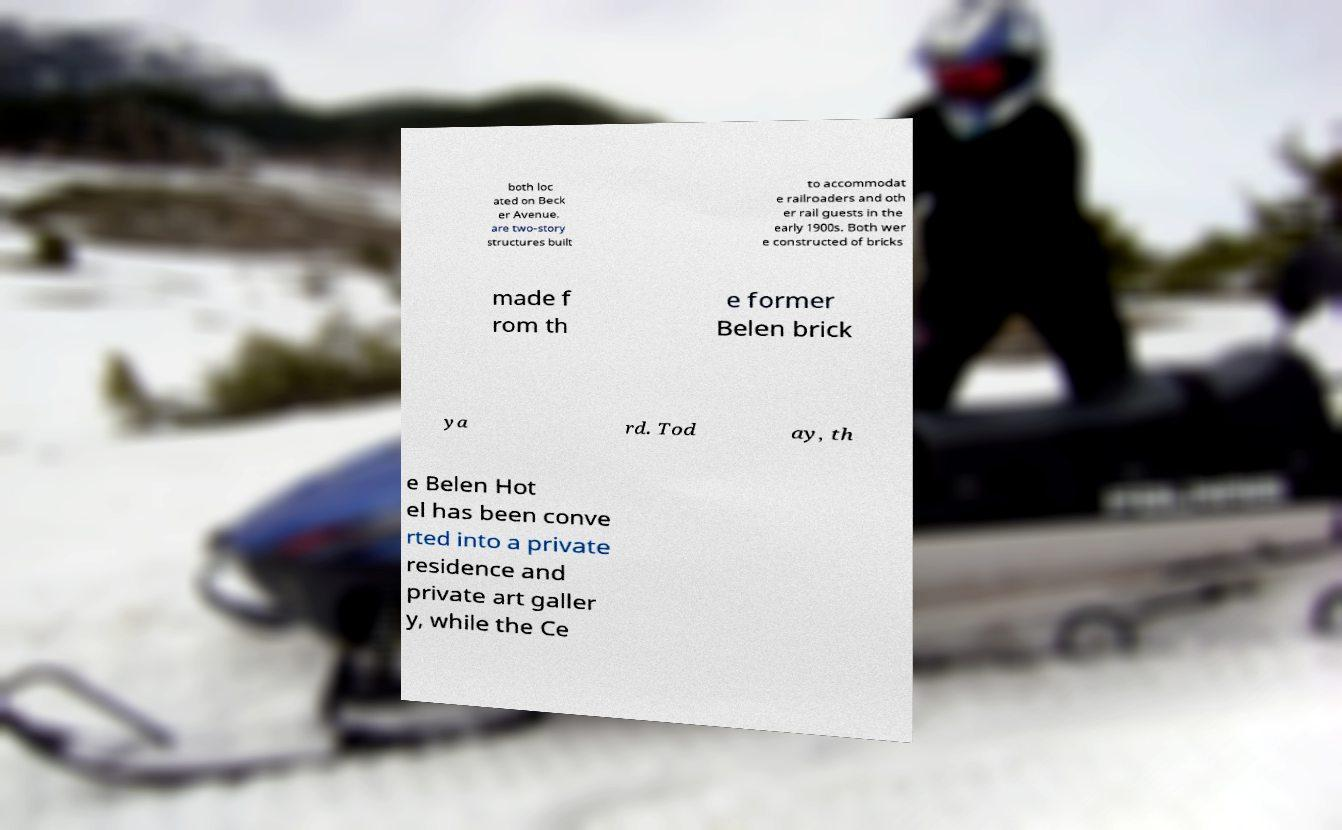Could you assist in decoding the text presented in this image and type it out clearly? both loc ated on Beck er Avenue, are two-story structures built to accommodat e railroaders and oth er rail guests in the early 1900s. Both wer e constructed of bricks made f rom th e former Belen brick ya rd. Tod ay, th e Belen Hot el has been conve rted into a private residence and private art galler y, while the Ce 